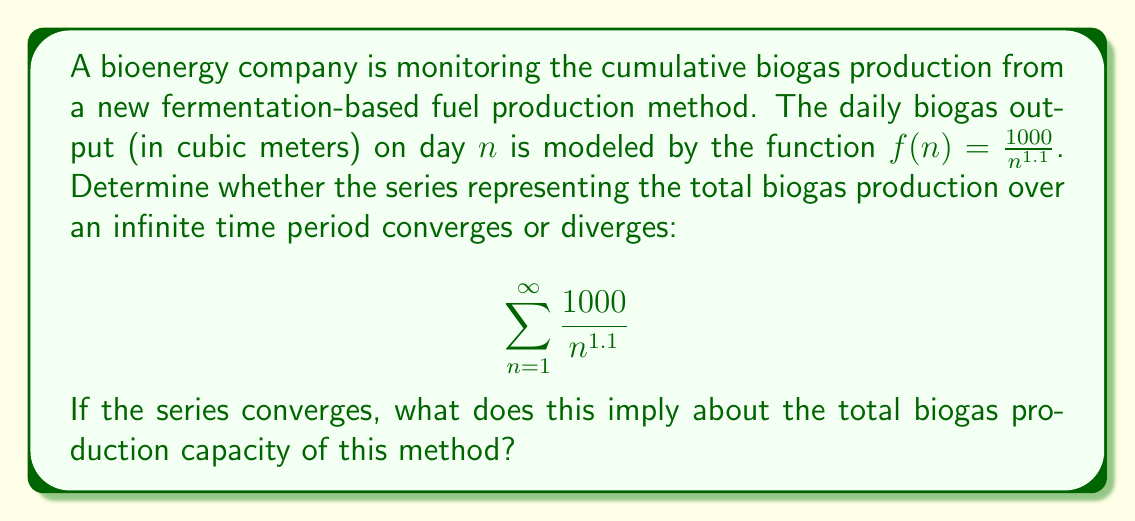Could you help me with this problem? To determine the convergence of this series, we can use the p-series test:

1) The general form of a p-series is $\sum_{n=1}^{\infty} \frac{1}{n^p}$

2) Our series can be rewritten as $1000 \sum_{n=1}^{\infty} \frac{1}{n^{1.1}}$, which is a constant multiple of a p-series with $p = 1.1$

3) For a p-series:
   - If $p > 1$, the series converges
   - If $p \leq 1$, the series diverges

4) In our case, $p = 1.1 > 1$, so the series converges

5) The constant multiple 1000 doesn't affect convergence, so the original series also converges

To interpret this result:

The convergence of the series implies that there is a finite limit to the total biogas production over an infinite time period. This means that the cumulative biogas production approaches a maximum value as time goes to infinity.

This has important implications for the sustainability manager:
- There is a theoretical maximum total biogas yield for this production method
- The daily biogas production will decrease over time, eventually becoming negligible
- The production method may need to be optimized or restarted periodically to maintain significant output
Answer: The series converges. This implies that the total biogas production capacity of this fermentation-based fuel production method has a finite upper limit over an infinite time period. 